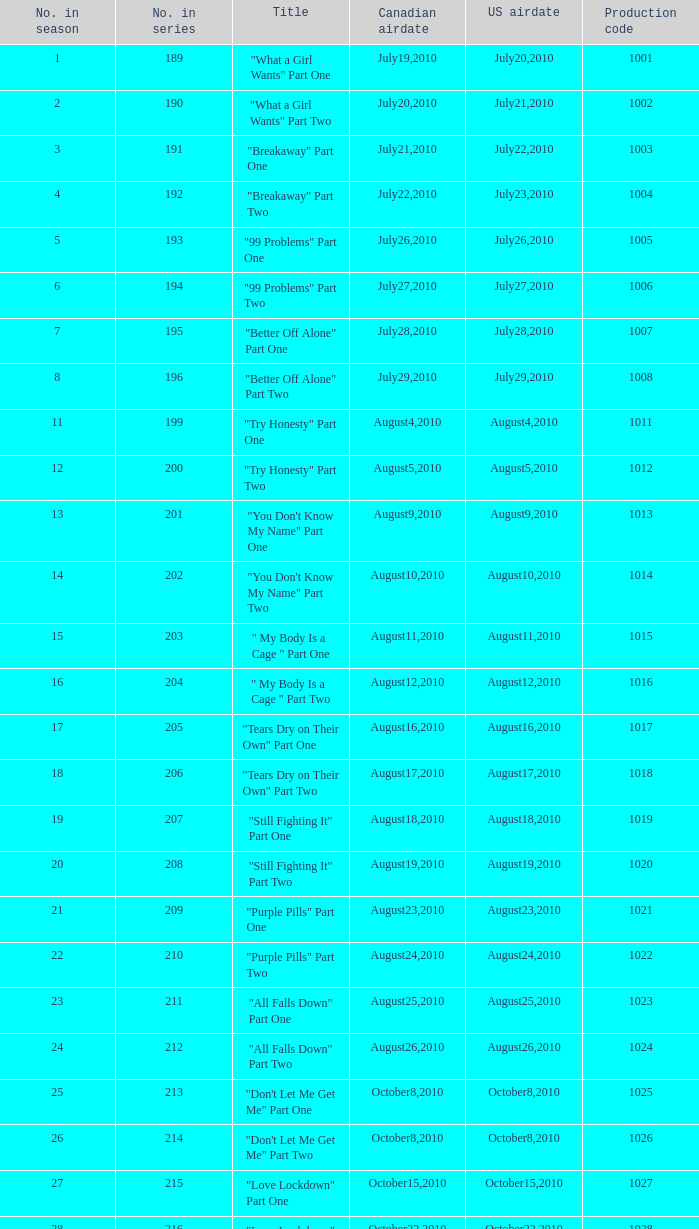How many titles had production code 1040? 1.0. 